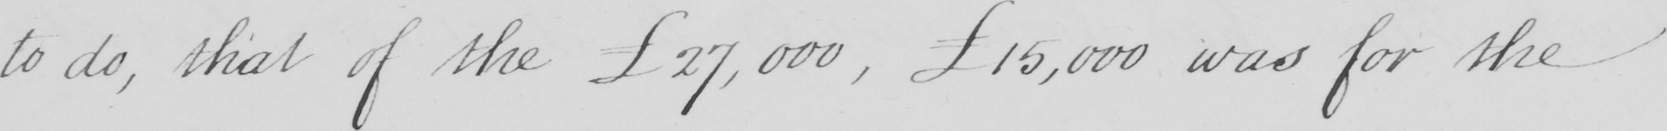What is written in this line of handwriting? to do , that of the £27,000 , £15,000 was for the 